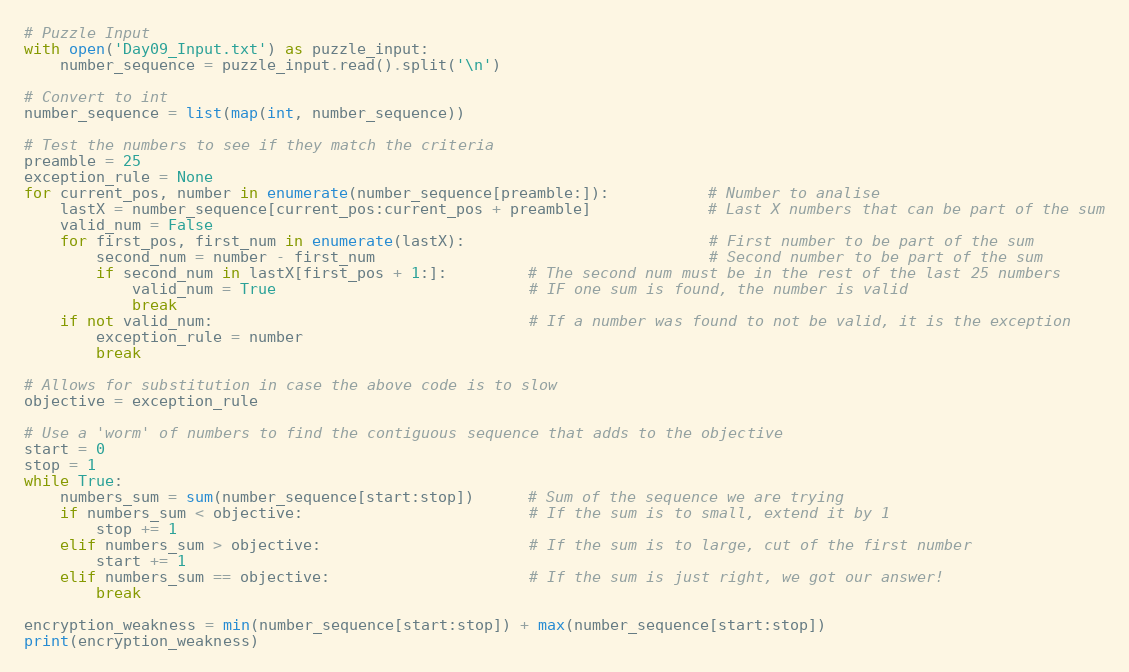Convert code to text. <code><loc_0><loc_0><loc_500><loc_500><_Python_># Puzzle Input
with open('Day09_Input.txt') as puzzle_input:
    number_sequence = puzzle_input.read().split('\n')

# Convert to int
number_sequence = list(map(int, number_sequence))

# Test the numbers to see if they match the criteria
preamble = 25
exception_rule = None
for current_pos, number in enumerate(number_sequence[preamble:]):           # Number to analise
    lastX = number_sequence[current_pos:current_pos + preamble]             # Last X numbers that can be part of the sum
    valid_num = False
    for first_pos, first_num in enumerate(lastX):                           # First number to be part of the sum
        second_num = number - first_num                                     # Second number to be part of the sum
        if second_num in lastX[first_pos + 1:]:         # The second num must be in the rest of the last 25 numbers
            valid_num = True                            # IF one sum is found, the number is valid
            break
    if not valid_num:                                   # If a number was found to not be valid, it is the exception
        exception_rule = number
        break

# Allows for substitution in case the above code is to slow
objective = exception_rule

# Use a 'worm' of numbers to find the contiguous sequence that adds to the objective
start = 0
stop = 1
while True:
    numbers_sum = sum(number_sequence[start:stop])      # Sum of the sequence we are trying
    if numbers_sum < objective:                         # If the sum is to small, extend it by 1
        stop += 1
    elif numbers_sum > objective:                       # If the sum is to large, cut of the first number
        start += 1
    elif numbers_sum == objective:                      # If the sum is just right, we got our answer!
        break

encryption_weakness = min(number_sequence[start:stop]) + max(number_sequence[start:stop])
print(encryption_weakness)
</code> 